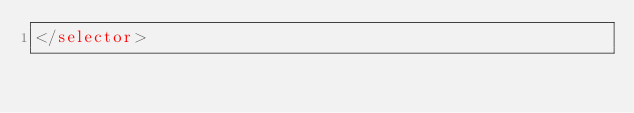Convert code to text. <code><loc_0><loc_0><loc_500><loc_500><_XML_></selector></code> 